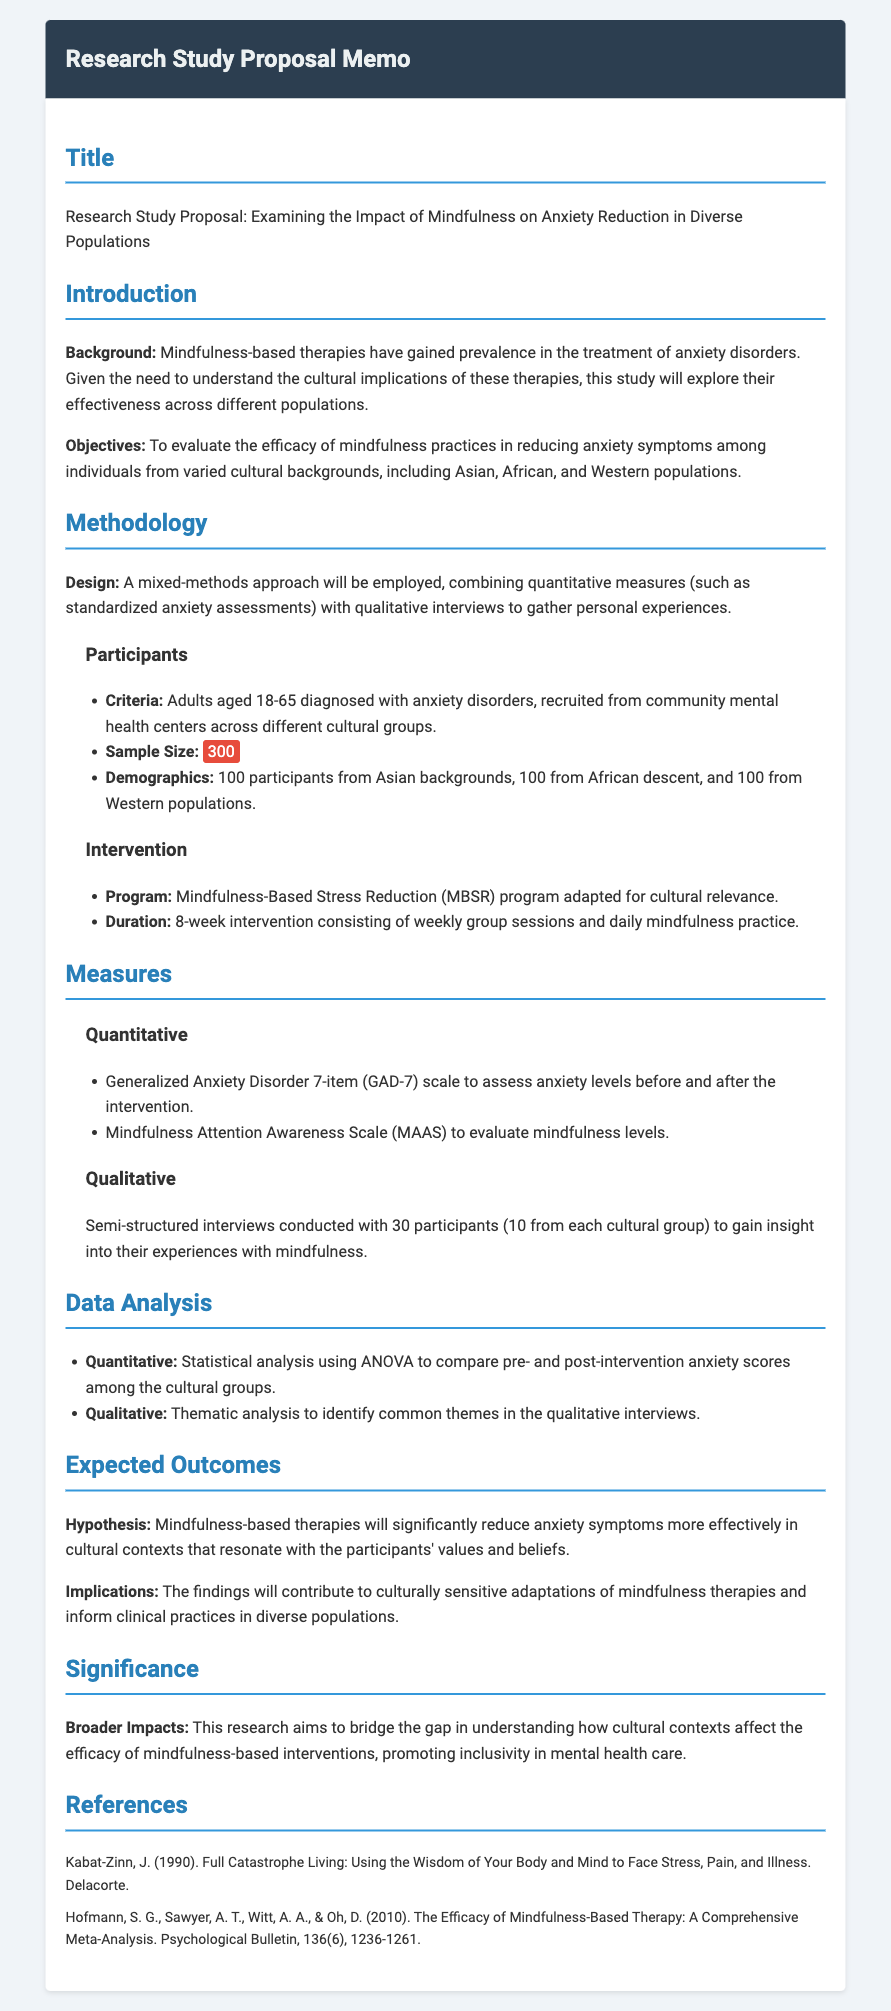What is the title of the study? The title is the main subject of the memo and is clearly stated at the beginning.
Answer: Examining the Impact of Mindfulness on Anxiety Reduction in Diverse Populations What is the sample size? The sample size is a significant detail mentioned under the participant criteria in the methodology section.
Answer: 300 How many participants will be from Asian backgrounds? The number of participants from each cultural background is specified in the demographics section.
Answer: 100 What type of analysis will be used for quantitative data? The type of statistical analysis is specified in the data analysis section of the memo.
Answer: ANOVA How long will the intervention last? The duration of the intervention is detailed in the methodology section under the intervention subheading.
Answer: 8-week intervention What is the primary hypothesis of the study? The hypothesis is stated under the expected outcomes section and reflects the anticipated results of the research.
Answer: Mindfulness-based therapies will significantly reduce anxiety symptoms more effectively in cultural contexts that resonate with the participants' values and beliefs What cultural populations are being studied? The diverse populations under examination are explicitly listed in the objectives of the study.
Answer: Asian, African, and Western populations What is the significance of this research? The broader impacts are explained in the significance section and highlight the purpose of the study.
Answer: Promote inclusivity in mental health care 